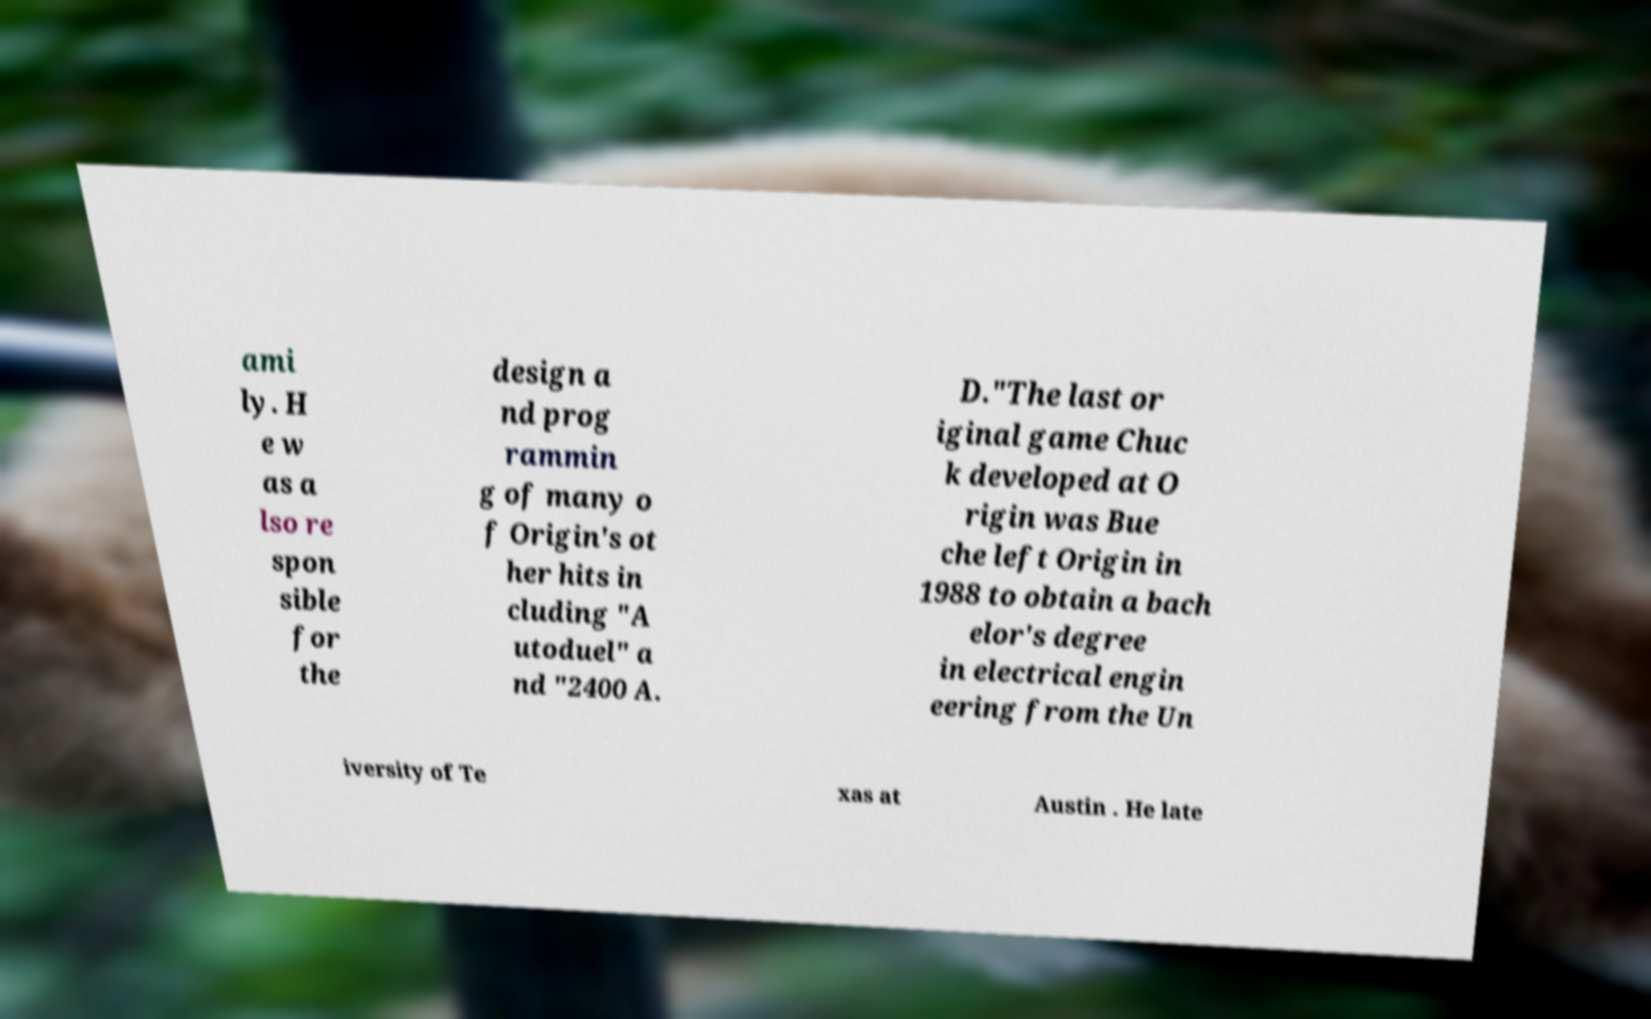There's text embedded in this image that I need extracted. Can you transcribe it verbatim? ami ly. H e w as a lso re spon sible for the design a nd prog rammin g of many o f Origin's ot her hits in cluding "A utoduel" a nd "2400 A. D."The last or iginal game Chuc k developed at O rigin was Bue che left Origin in 1988 to obtain a bach elor's degree in electrical engin eering from the Un iversity of Te xas at Austin . He late 